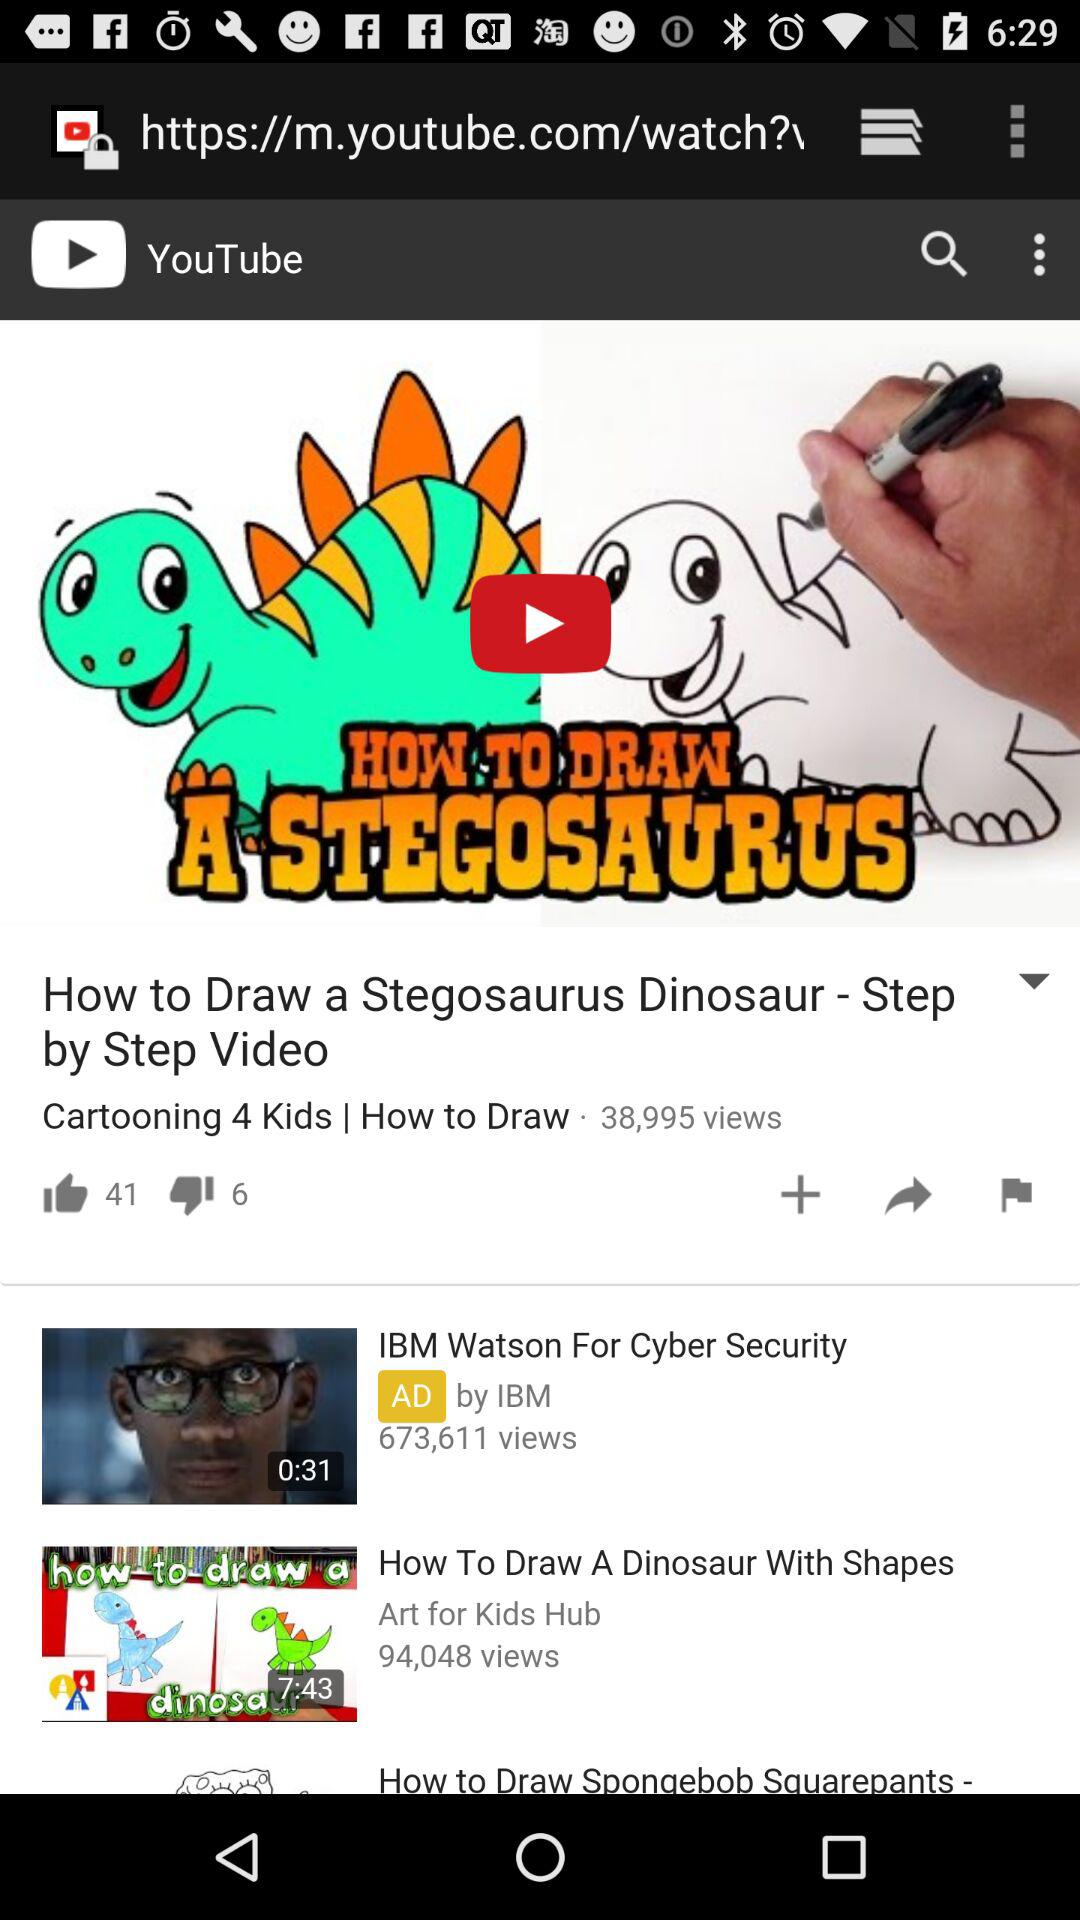What is the time duration of the video "How To Draw A Dinosaur With Shapes"? The time duration is 7 minutes 43 seconds. 